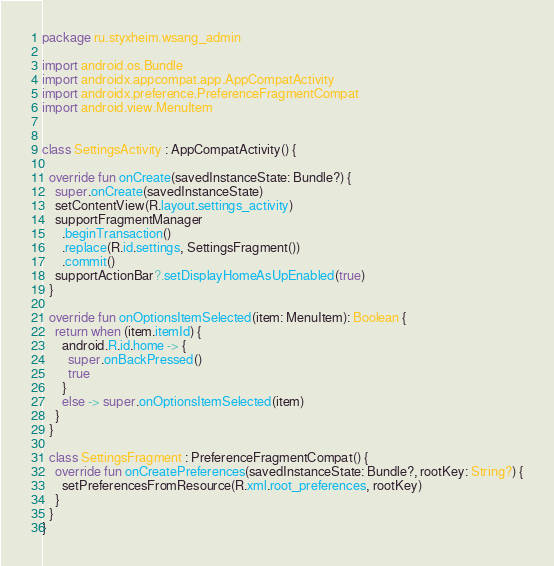<code> <loc_0><loc_0><loc_500><loc_500><_Kotlin_>package ru.styxheim.wsang_admin

import android.os.Bundle
import androidx.appcompat.app.AppCompatActivity
import androidx.preference.PreferenceFragmentCompat
import android.view.MenuItem


class SettingsActivity : AppCompatActivity() {

  override fun onCreate(savedInstanceState: Bundle?) {
    super.onCreate(savedInstanceState)
    setContentView(R.layout.settings_activity)
    supportFragmentManager
      .beginTransaction()
      .replace(R.id.settings, SettingsFragment())
      .commit()
    supportActionBar?.setDisplayHomeAsUpEnabled(true)
  }

  override fun onOptionsItemSelected(item: MenuItem): Boolean {
    return when (item.itemId) {
      android.R.id.home -> {
        super.onBackPressed()
        true
      }
      else -> super.onOptionsItemSelected(item)
    }
  }

  class SettingsFragment : PreferenceFragmentCompat() {
    override fun onCreatePreferences(savedInstanceState: Bundle?, rootKey: String?) {
      setPreferencesFromResource(R.xml.root_preferences, rootKey)
    }
  }
}</code> 